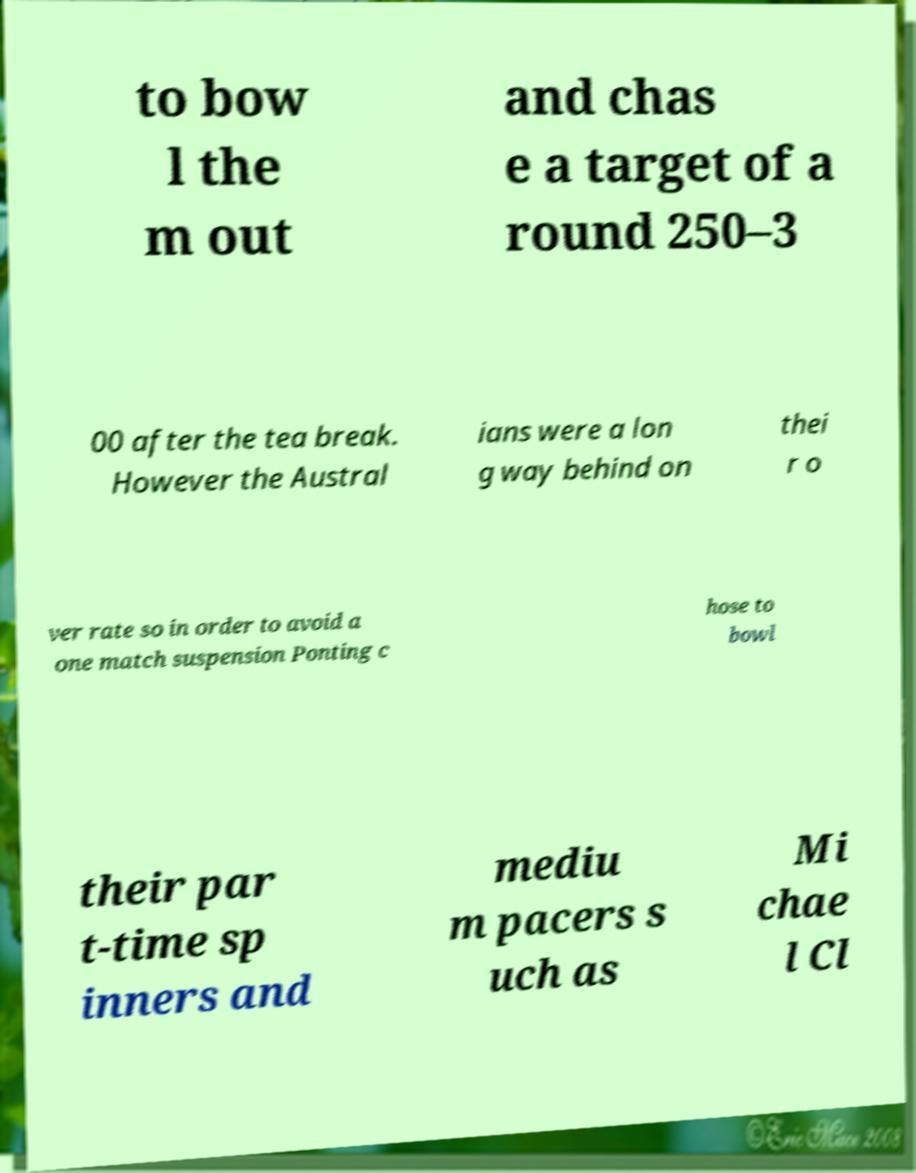Could you extract and type out the text from this image? to bow l the m out and chas e a target of a round 250–3 00 after the tea break. However the Austral ians were a lon g way behind on thei r o ver rate so in order to avoid a one match suspension Ponting c hose to bowl their par t-time sp inners and mediu m pacers s uch as Mi chae l Cl 